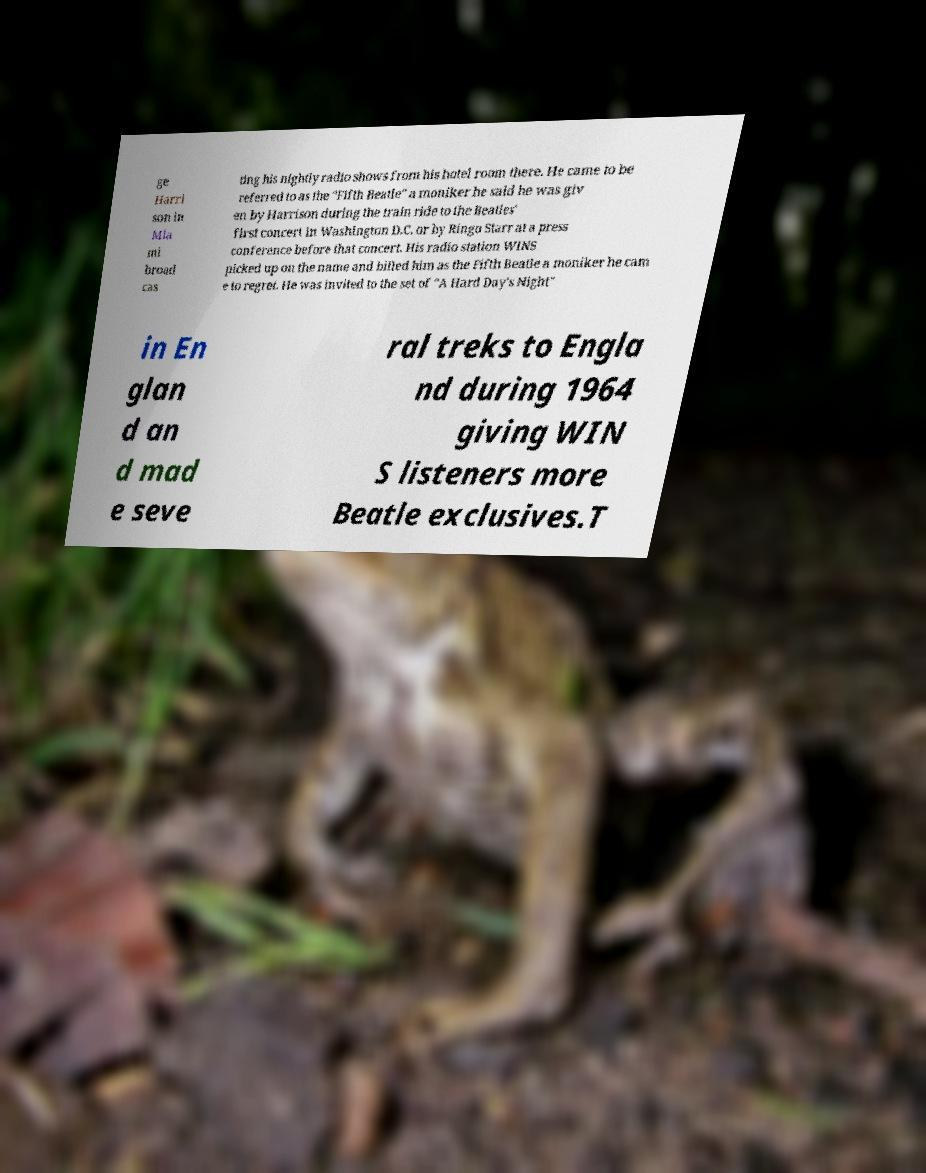Could you extract and type out the text from this image? ge Harri son in Mia mi broad cas ting his nightly radio shows from his hotel room there. He came to be referred to as the "Fifth Beatle" a moniker he said he was giv en by Harrison during the train ride to the Beatles' first concert in Washington D.C. or by Ringo Starr at a press conference before that concert. His radio station WINS picked up on the name and billed him as the Fifth Beatle a moniker he cam e to regret. He was invited to the set of "A Hard Day's Night" in En glan d an d mad e seve ral treks to Engla nd during 1964 giving WIN S listeners more Beatle exclusives.T 